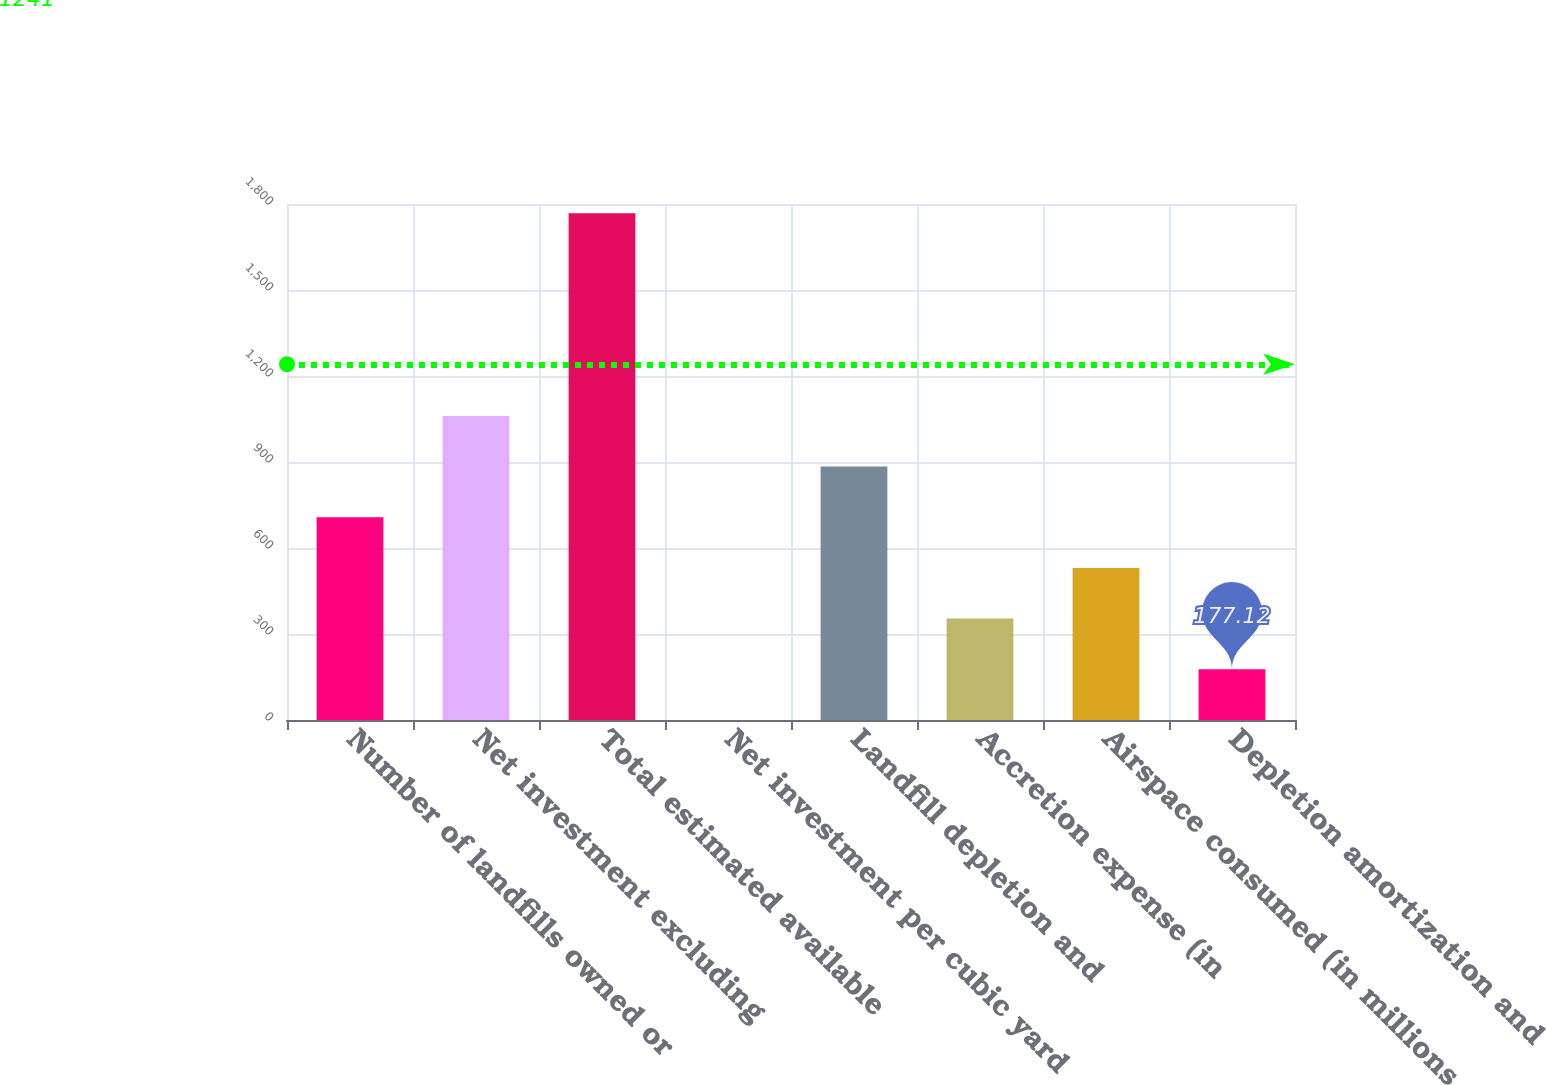Convert chart. <chart><loc_0><loc_0><loc_500><loc_500><bar_chart><fcel>Number of landfills owned or<fcel>Net investment excluding<fcel>Total estimated available<fcel>Net investment per cubic yard<fcel>Landfill depletion and<fcel>Accretion expense (in<fcel>Airspace consumed (in millions<fcel>Depletion amortization and<nl><fcel>707.19<fcel>1060.57<fcel>1767.3<fcel>0.43<fcel>883.88<fcel>353.81<fcel>530.5<fcel>177.12<nl></chart> 